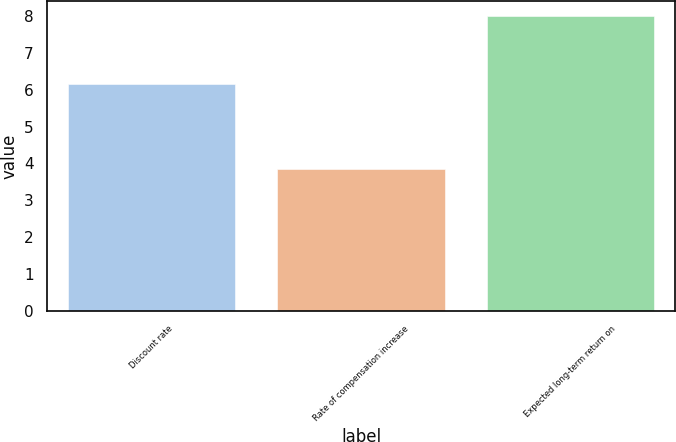Convert chart to OTSL. <chart><loc_0><loc_0><loc_500><loc_500><bar_chart><fcel>Discount rate<fcel>Rate of compensation increase<fcel>Expected long-term return on<nl><fcel>6.16<fcel>3.84<fcel>8<nl></chart> 